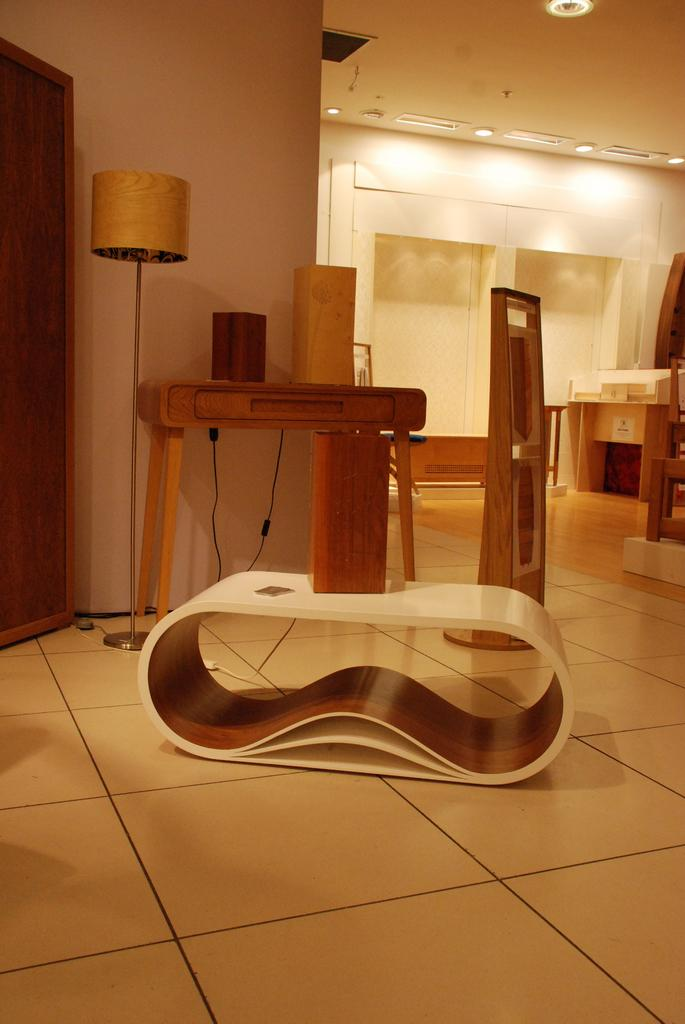What type of space is shown in the image? The image shows the inner view of a room. What type of lighting is present in the room? There are electric lights and a table lamp in the room. What type of furniture can be seen in the room? There is a wardrobe, a side table, and a desk in the room. What else is present in the room besides furniture? Cables are present in the room. What part of the room is visible in the image? The floor is visible in the room. Where is the map displayed in the room? There is no map present in the image. What type of cake is on the side table in the room? There is no cake present in the image. 